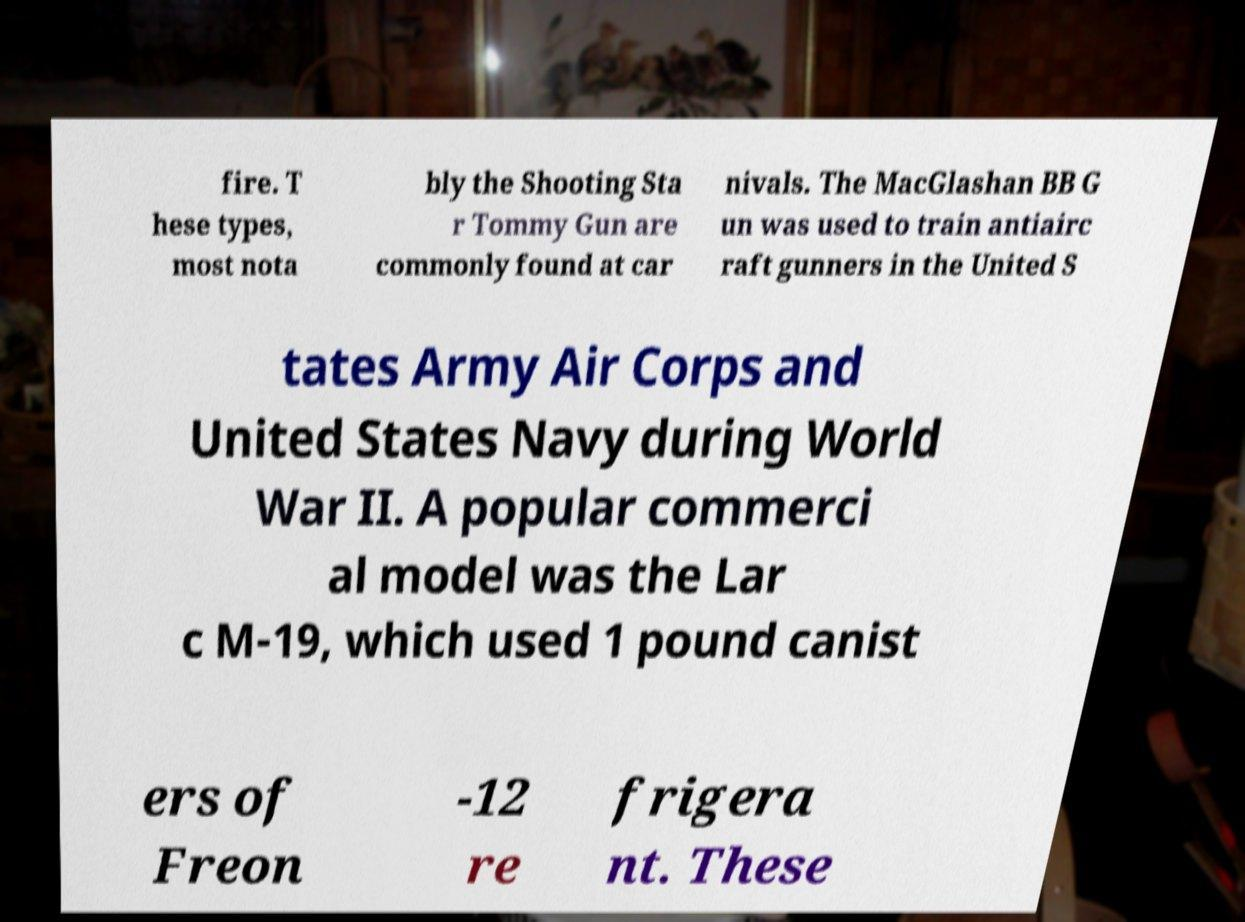Could you assist in decoding the text presented in this image and type it out clearly? fire. T hese types, most nota bly the Shooting Sta r Tommy Gun are commonly found at car nivals. The MacGlashan BB G un was used to train antiairc raft gunners in the United S tates Army Air Corps and United States Navy during World War II. A popular commerci al model was the Lar c M-19, which used 1 pound canist ers of Freon -12 re frigera nt. These 